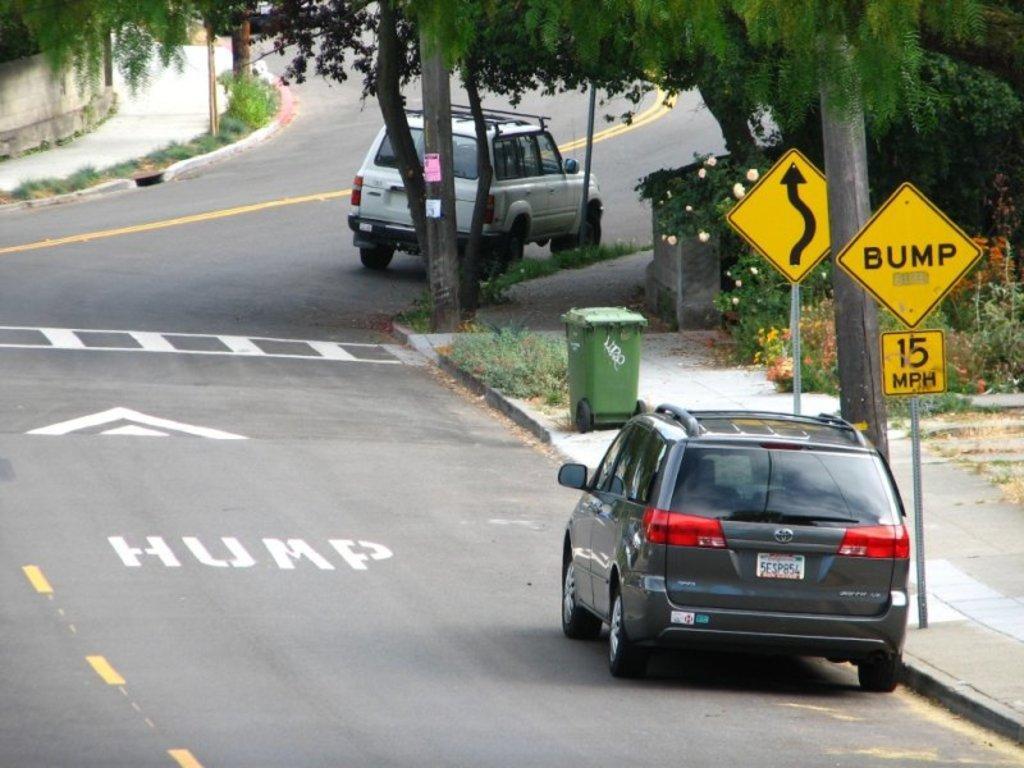Describe this image in one or two sentences. In this image, we can see vehicles on the road. There are tree and plants in the top right of the image. There are sign boards on the right side of the image. There is a trash bin on the footpath. 